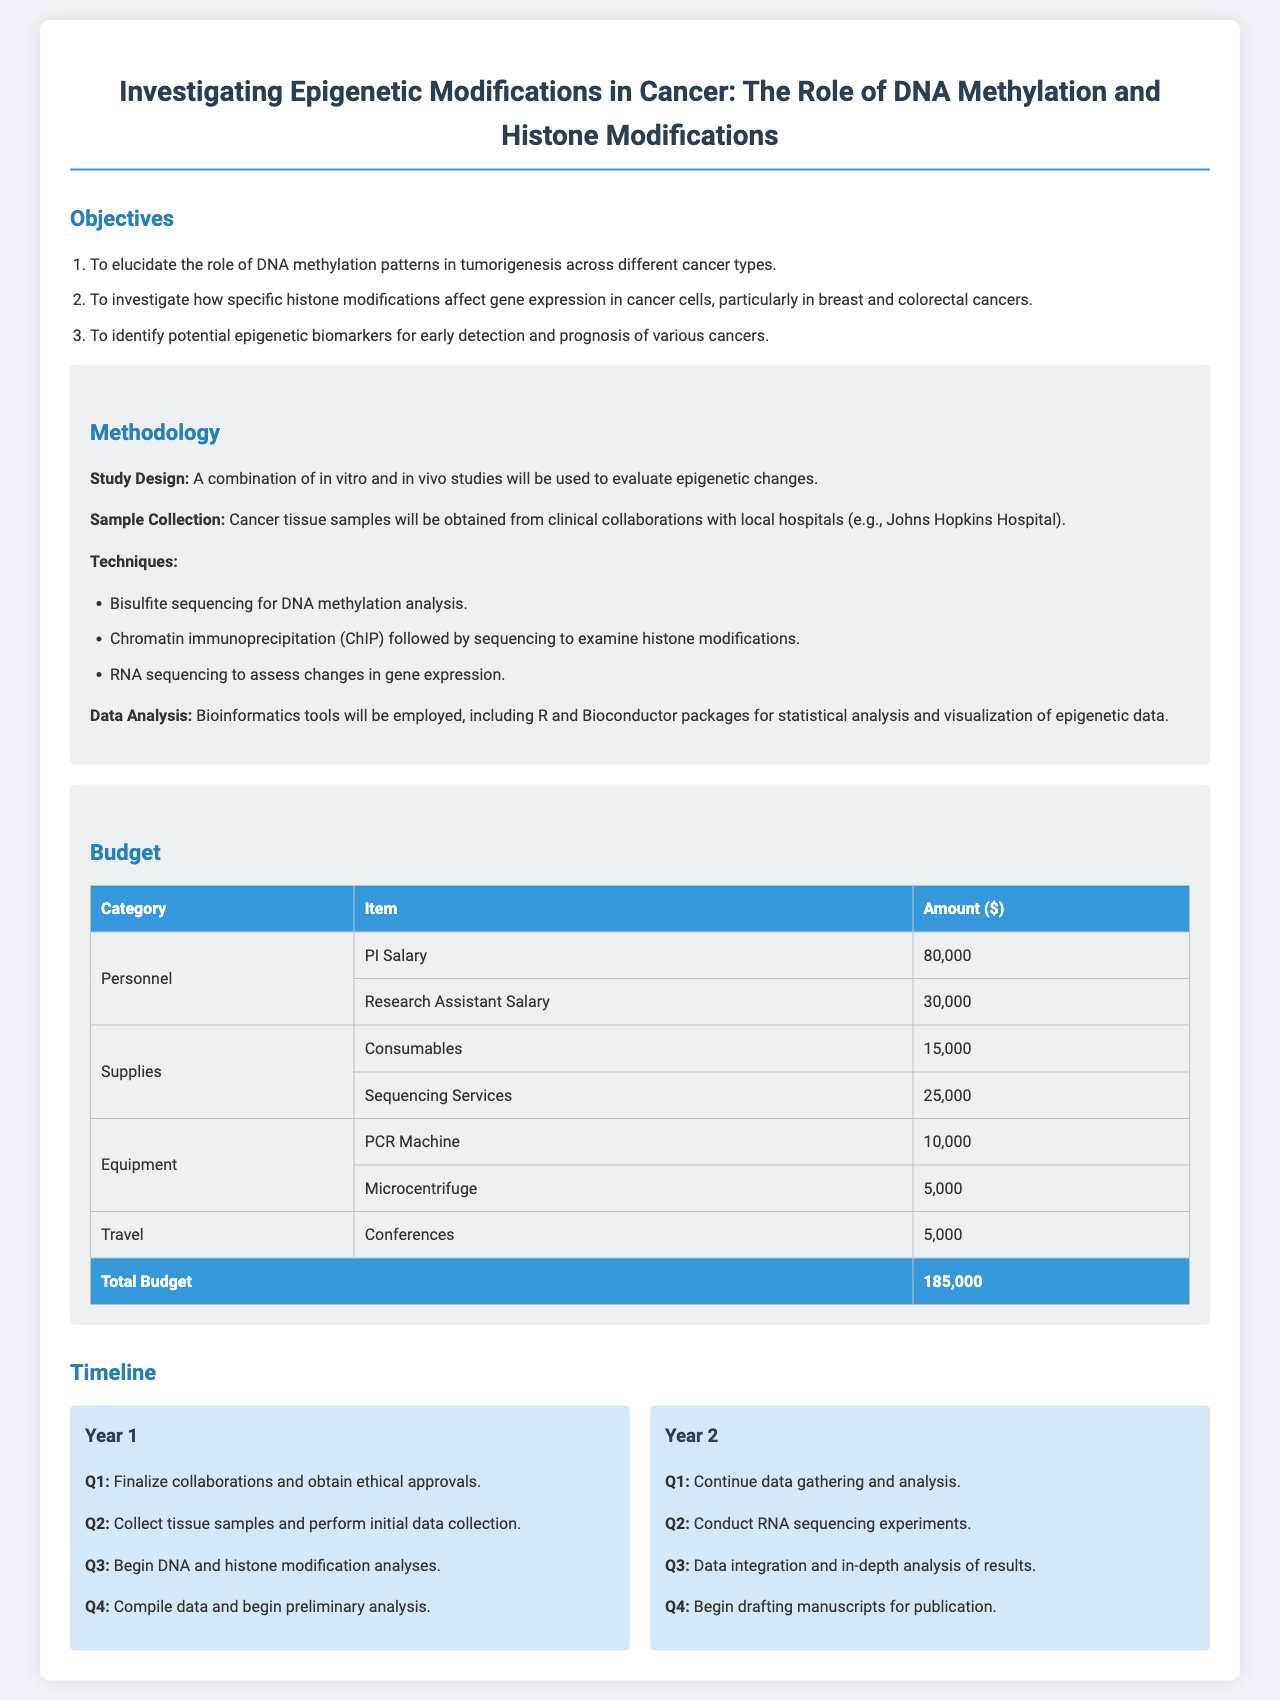what is the title of the project? The title of the project is stated in the header of the document.
Answer: Investigating Epigenetic Modifications in Cancer: The Role of DNA Methylation and Histone Modifications how much is allocated for sequencing services? The amount for sequencing services is found in the budget section under supplies.
Answer: 25,000 what is the total budget for the project? The total budget is the sum of all expenses listed at the end of the budget table.
Answer: 185,000 which cancer types are specifically mentioned in the objectives? The cancer types are listed in the second objective under the objectives section.
Answer: breast and colorectal cancers what technique will be used for DNA methylation analysis? The technique is mentioned in the methodology section regarding the specific techniques employed.
Answer: Bisulfite sequencing what will the PI salary be according to the budget? The PI salary is listed in the budget section under personnel.
Answer: 80,000 what is the goal of Year 2 Q4 in the timeline? The timeline describes activities for each quarter, with specific goals mentioned for Year 2 Q4.
Answer: Begin drafting manuscripts for publication how many quarters are specified for Year 1 in the timeline? The timeline includes quarterly details for Year 1, which lays out actions for each quarter.
Answer: 4 what are the main components of data analysis mentioned? The main components are included in the methodology section under data analysis.
Answer: Bioinformatics tools, R and Bioconductor packages 